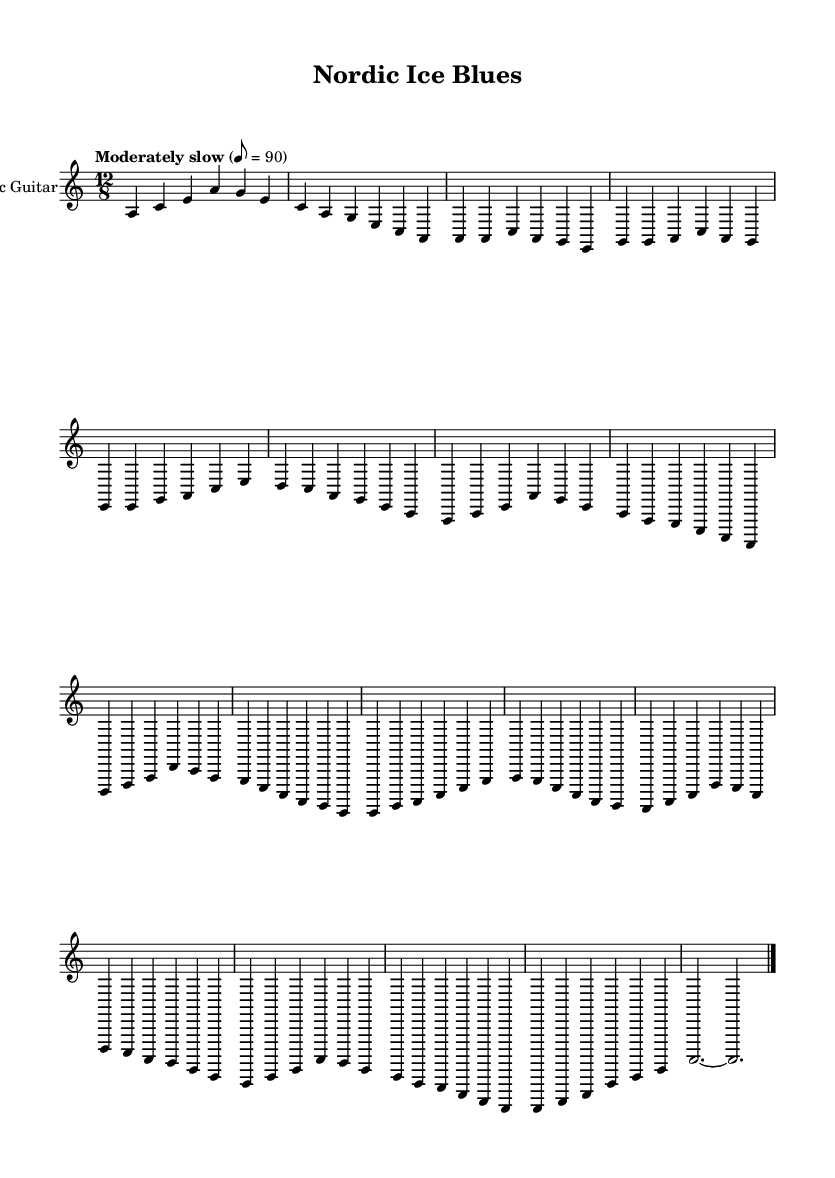What is the key signature of this music? The key signature indicates the presence of A minor, which has no sharps or flats. This can be inferred from the note placements and the absence of accidentals throughout the piece.
Answer: A minor What is the time signature of this music? The time signature is found at the beginning of the sheet music, specified as 12/8. This indicates a compound time signature where there are four beat groups of three eighth notes, creating a shuffle feel typical in blues music.
Answer: 12/8 What is the tempo marking given for this piece? The tempo marking states "Moderately slow" with a metronome marking of 8 = 90, which means the piece should be played at a pace of 90 beats per minute. This is usually specified at the beginning of the score.
Answer: Moderately slow How many sections does the piece have? The piece contains five distinct sections; an intro, a verse, a chorus, a bridge, and an outro. Each section is represented by a specific musical structure and pattern that corresponds to typical blues song formats.
Answer: Five Which musical instrument is specified in this sheet music? The instrument indicated in the sheet music is the electric guitar. This is noted in the staff label, which designates the standard instrumental nomenclature for this piece.
Answer: Electric guitar What is the first chord played in the intro? The first chord played in the intro is A minor, represented by the note A alongside other notes that align with the A minor chord structure. Observing the first measure confirms the chord.
Answer: A minor 